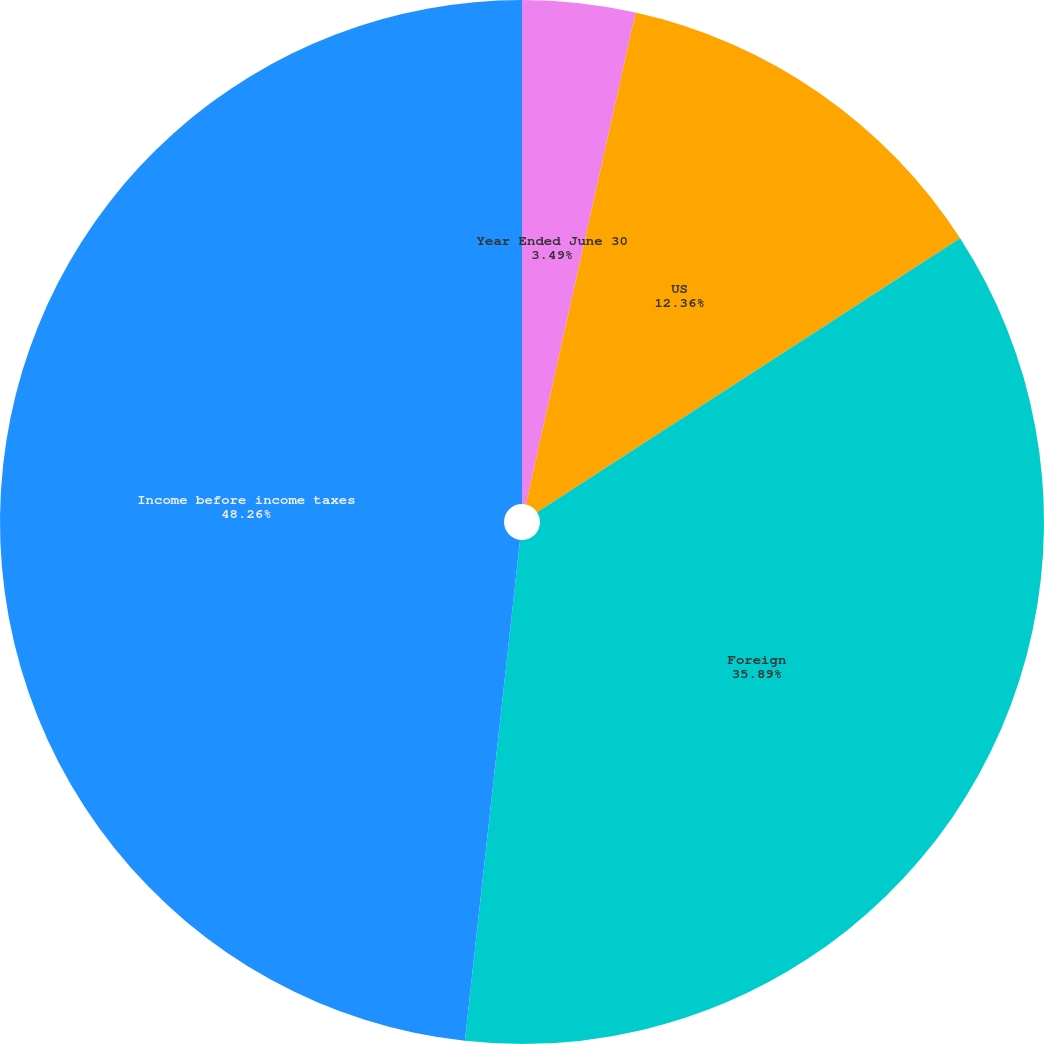<chart> <loc_0><loc_0><loc_500><loc_500><pie_chart><fcel>Year Ended June 30<fcel>US<fcel>Foreign<fcel>Income before income taxes<nl><fcel>3.49%<fcel>12.36%<fcel>35.89%<fcel>48.25%<nl></chart> 